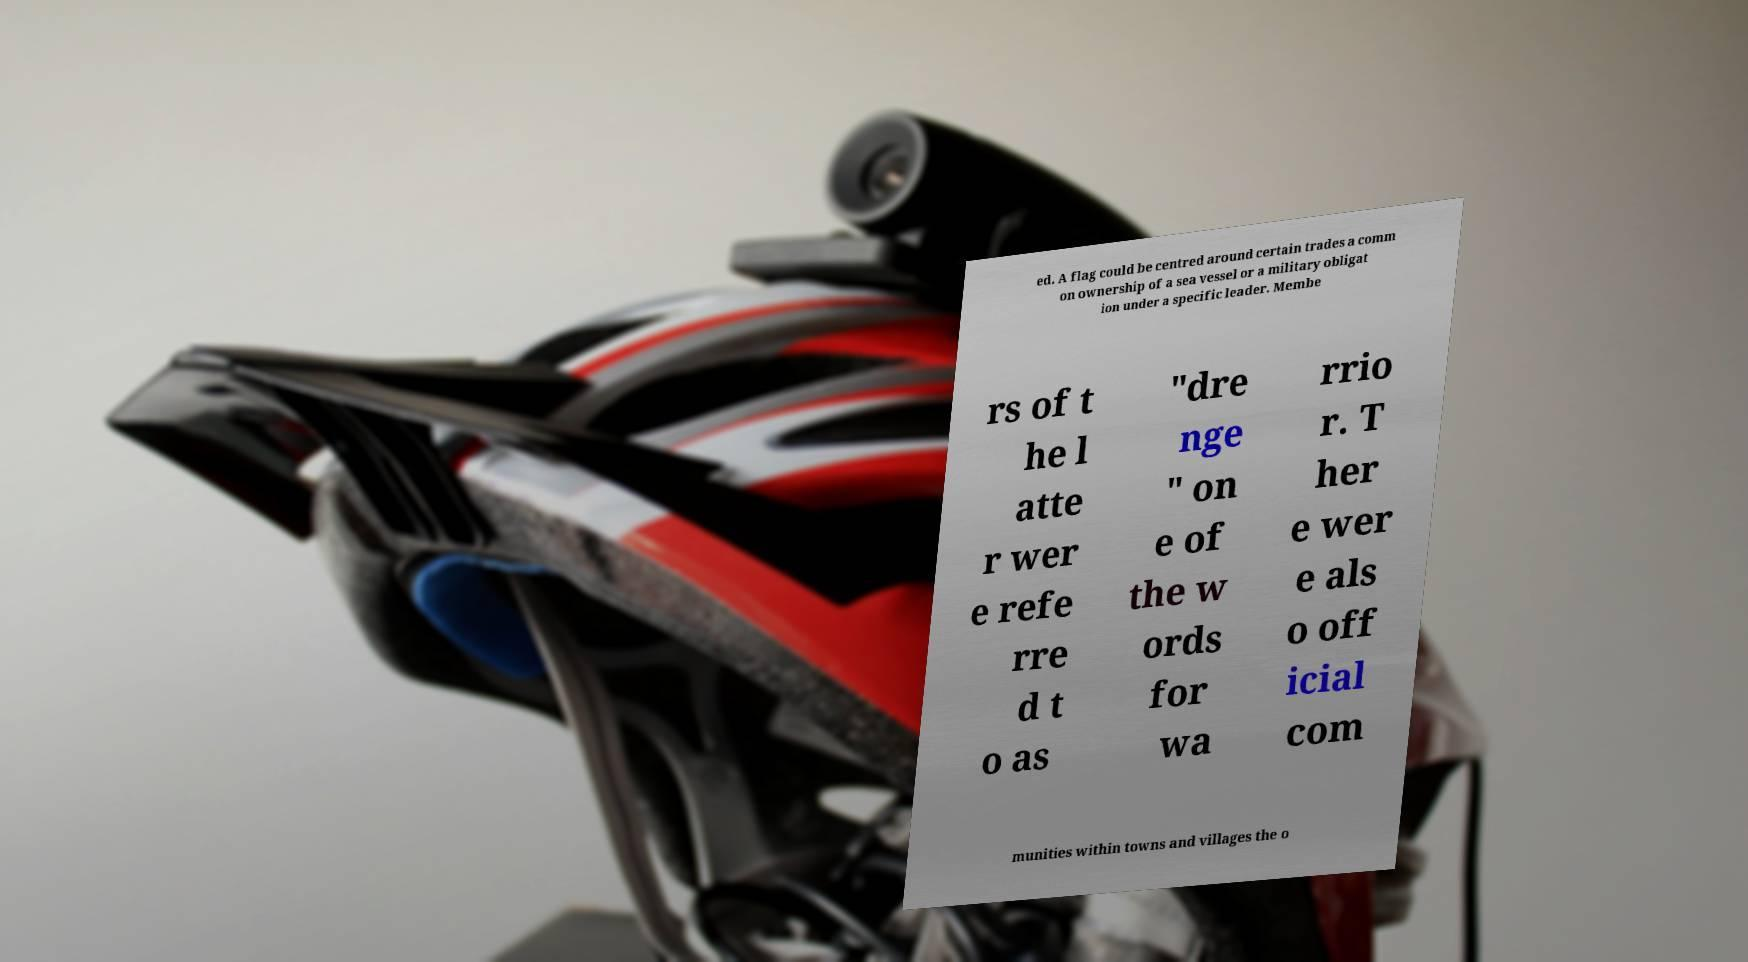What messages or text are displayed in this image? I need them in a readable, typed format. ed. A flag could be centred around certain trades a comm on ownership of a sea vessel or a military obligat ion under a specific leader. Membe rs of t he l atte r wer e refe rre d t o as "dre nge " on e of the w ords for wa rrio r. T her e wer e als o off icial com munities within towns and villages the o 